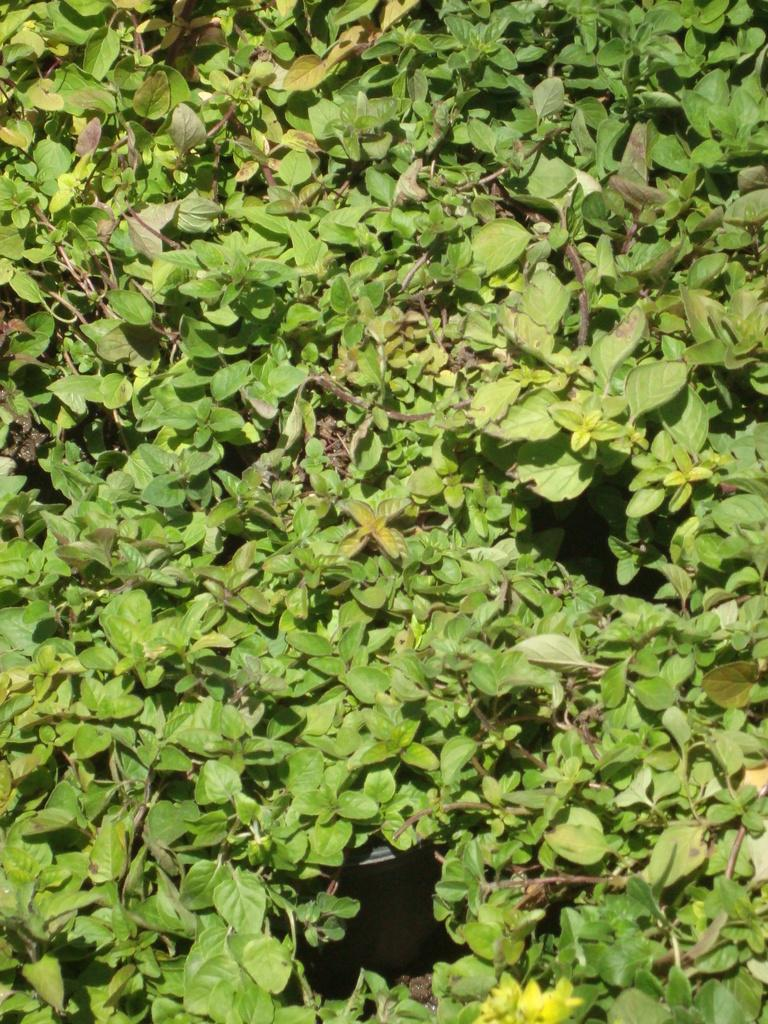What type of plant material is present in the image? There are leaves and stems in the image. Can you describe the appearance of the leaves? The provided facts do not include a description of the leaves' appearance. What might be the purpose of the stems in the image? The purpose of the stems in the image is not specified in the provided facts. What type of advertisement is displayed on the leaves in the image? There is no advertisement present on the leaves in the image; the provided facts only mention the presence of leaves and stems. How is the popcorn served with butter in the image? There is no popcorn or butter present in the image; the provided facts only mention the presence of leaves and stems. 